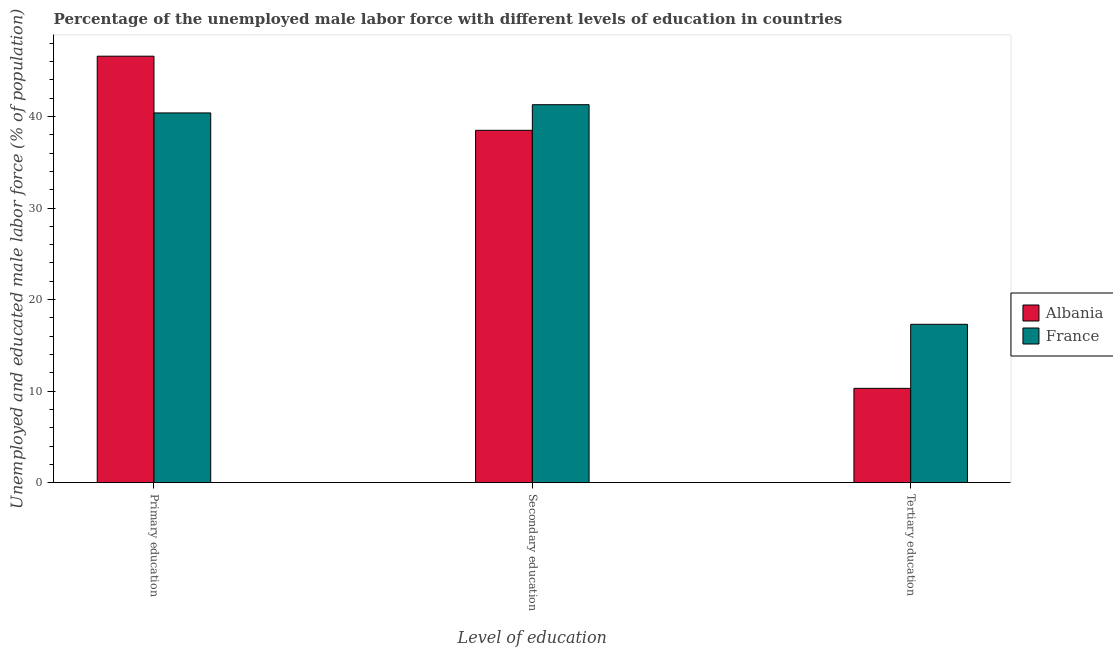How many different coloured bars are there?
Your answer should be compact. 2. How many groups of bars are there?
Ensure brevity in your answer.  3. How many bars are there on the 3rd tick from the left?
Provide a succinct answer. 2. How many bars are there on the 1st tick from the right?
Your response must be concise. 2. What is the label of the 1st group of bars from the left?
Provide a short and direct response. Primary education. What is the percentage of male labor force who received primary education in France?
Keep it short and to the point. 40.4. Across all countries, what is the maximum percentage of male labor force who received secondary education?
Ensure brevity in your answer.  41.3. Across all countries, what is the minimum percentage of male labor force who received primary education?
Keep it short and to the point. 40.4. In which country was the percentage of male labor force who received primary education maximum?
Provide a succinct answer. Albania. In which country was the percentage of male labor force who received primary education minimum?
Your answer should be compact. France. What is the total percentage of male labor force who received secondary education in the graph?
Give a very brief answer. 79.8. What is the difference between the percentage of male labor force who received secondary education in France and that in Albania?
Give a very brief answer. 2.8. What is the difference between the percentage of male labor force who received primary education in Albania and the percentage of male labor force who received secondary education in France?
Your response must be concise. 5.3. What is the average percentage of male labor force who received tertiary education per country?
Your answer should be very brief. 13.8. What is the difference between the percentage of male labor force who received secondary education and percentage of male labor force who received tertiary education in France?
Give a very brief answer. 24. What is the ratio of the percentage of male labor force who received tertiary education in France to that in Albania?
Ensure brevity in your answer.  1.68. What is the difference between the highest and the second highest percentage of male labor force who received primary education?
Provide a succinct answer. 6.2. What is the difference between the highest and the lowest percentage of male labor force who received secondary education?
Offer a very short reply. 2.8. Is the sum of the percentage of male labor force who received tertiary education in France and Albania greater than the maximum percentage of male labor force who received primary education across all countries?
Offer a terse response. No. What does the 1st bar from the right in Secondary education represents?
Provide a succinct answer. France. How many countries are there in the graph?
Your answer should be compact. 2. What is the difference between two consecutive major ticks on the Y-axis?
Your answer should be compact. 10. Where does the legend appear in the graph?
Your answer should be very brief. Center right. How many legend labels are there?
Your answer should be very brief. 2. What is the title of the graph?
Keep it short and to the point. Percentage of the unemployed male labor force with different levels of education in countries. Does "United Arab Emirates" appear as one of the legend labels in the graph?
Your answer should be very brief. No. What is the label or title of the X-axis?
Your response must be concise. Level of education. What is the label or title of the Y-axis?
Offer a terse response. Unemployed and educated male labor force (% of population). What is the Unemployed and educated male labor force (% of population) in Albania in Primary education?
Provide a succinct answer. 46.6. What is the Unemployed and educated male labor force (% of population) of France in Primary education?
Your answer should be very brief. 40.4. What is the Unemployed and educated male labor force (% of population) in Albania in Secondary education?
Your response must be concise. 38.5. What is the Unemployed and educated male labor force (% of population) in France in Secondary education?
Make the answer very short. 41.3. What is the Unemployed and educated male labor force (% of population) of Albania in Tertiary education?
Your answer should be compact. 10.3. What is the Unemployed and educated male labor force (% of population) in France in Tertiary education?
Make the answer very short. 17.3. Across all Level of education, what is the maximum Unemployed and educated male labor force (% of population) in Albania?
Ensure brevity in your answer.  46.6. Across all Level of education, what is the maximum Unemployed and educated male labor force (% of population) in France?
Offer a terse response. 41.3. Across all Level of education, what is the minimum Unemployed and educated male labor force (% of population) of Albania?
Offer a terse response. 10.3. Across all Level of education, what is the minimum Unemployed and educated male labor force (% of population) in France?
Your answer should be very brief. 17.3. What is the total Unemployed and educated male labor force (% of population) in Albania in the graph?
Provide a short and direct response. 95.4. What is the total Unemployed and educated male labor force (% of population) of France in the graph?
Provide a succinct answer. 99. What is the difference between the Unemployed and educated male labor force (% of population) in Albania in Primary education and that in Secondary education?
Provide a succinct answer. 8.1. What is the difference between the Unemployed and educated male labor force (% of population) in Albania in Primary education and that in Tertiary education?
Make the answer very short. 36.3. What is the difference between the Unemployed and educated male labor force (% of population) of France in Primary education and that in Tertiary education?
Your answer should be very brief. 23.1. What is the difference between the Unemployed and educated male labor force (% of population) in Albania in Secondary education and that in Tertiary education?
Offer a very short reply. 28.2. What is the difference between the Unemployed and educated male labor force (% of population) in France in Secondary education and that in Tertiary education?
Your response must be concise. 24. What is the difference between the Unemployed and educated male labor force (% of population) of Albania in Primary education and the Unemployed and educated male labor force (% of population) of France in Tertiary education?
Keep it short and to the point. 29.3. What is the difference between the Unemployed and educated male labor force (% of population) of Albania in Secondary education and the Unemployed and educated male labor force (% of population) of France in Tertiary education?
Make the answer very short. 21.2. What is the average Unemployed and educated male labor force (% of population) of Albania per Level of education?
Give a very brief answer. 31.8. What is the difference between the Unemployed and educated male labor force (% of population) in Albania and Unemployed and educated male labor force (% of population) in France in Primary education?
Keep it short and to the point. 6.2. What is the ratio of the Unemployed and educated male labor force (% of population) of Albania in Primary education to that in Secondary education?
Your response must be concise. 1.21. What is the ratio of the Unemployed and educated male labor force (% of population) of France in Primary education to that in Secondary education?
Your answer should be very brief. 0.98. What is the ratio of the Unemployed and educated male labor force (% of population) of Albania in Primary education to that in Tertiary education?
Give a very brief answer. 4.52. What is the ratio of the Unemployed and educated male labor force (% of population) in France in Primary education to that in Tertiary education?
Provide a succinct answer. 2.34. What is the ratio of the Unemployed and educated male labor force (% of population) of Albania in Secondary education to that in Tertiary education?
Provide a succinct answer. 3.74. What is the ratio of the Unemployed and educated male labor force (% of population) in France in Secondary education to that in Tertiary education?
Your answer should be compact. 2.39. What is the difference between the highest and the lowest Unemployed and educated male labor force (% of population) of Albania?
Your answer should be compact. 36.3. 